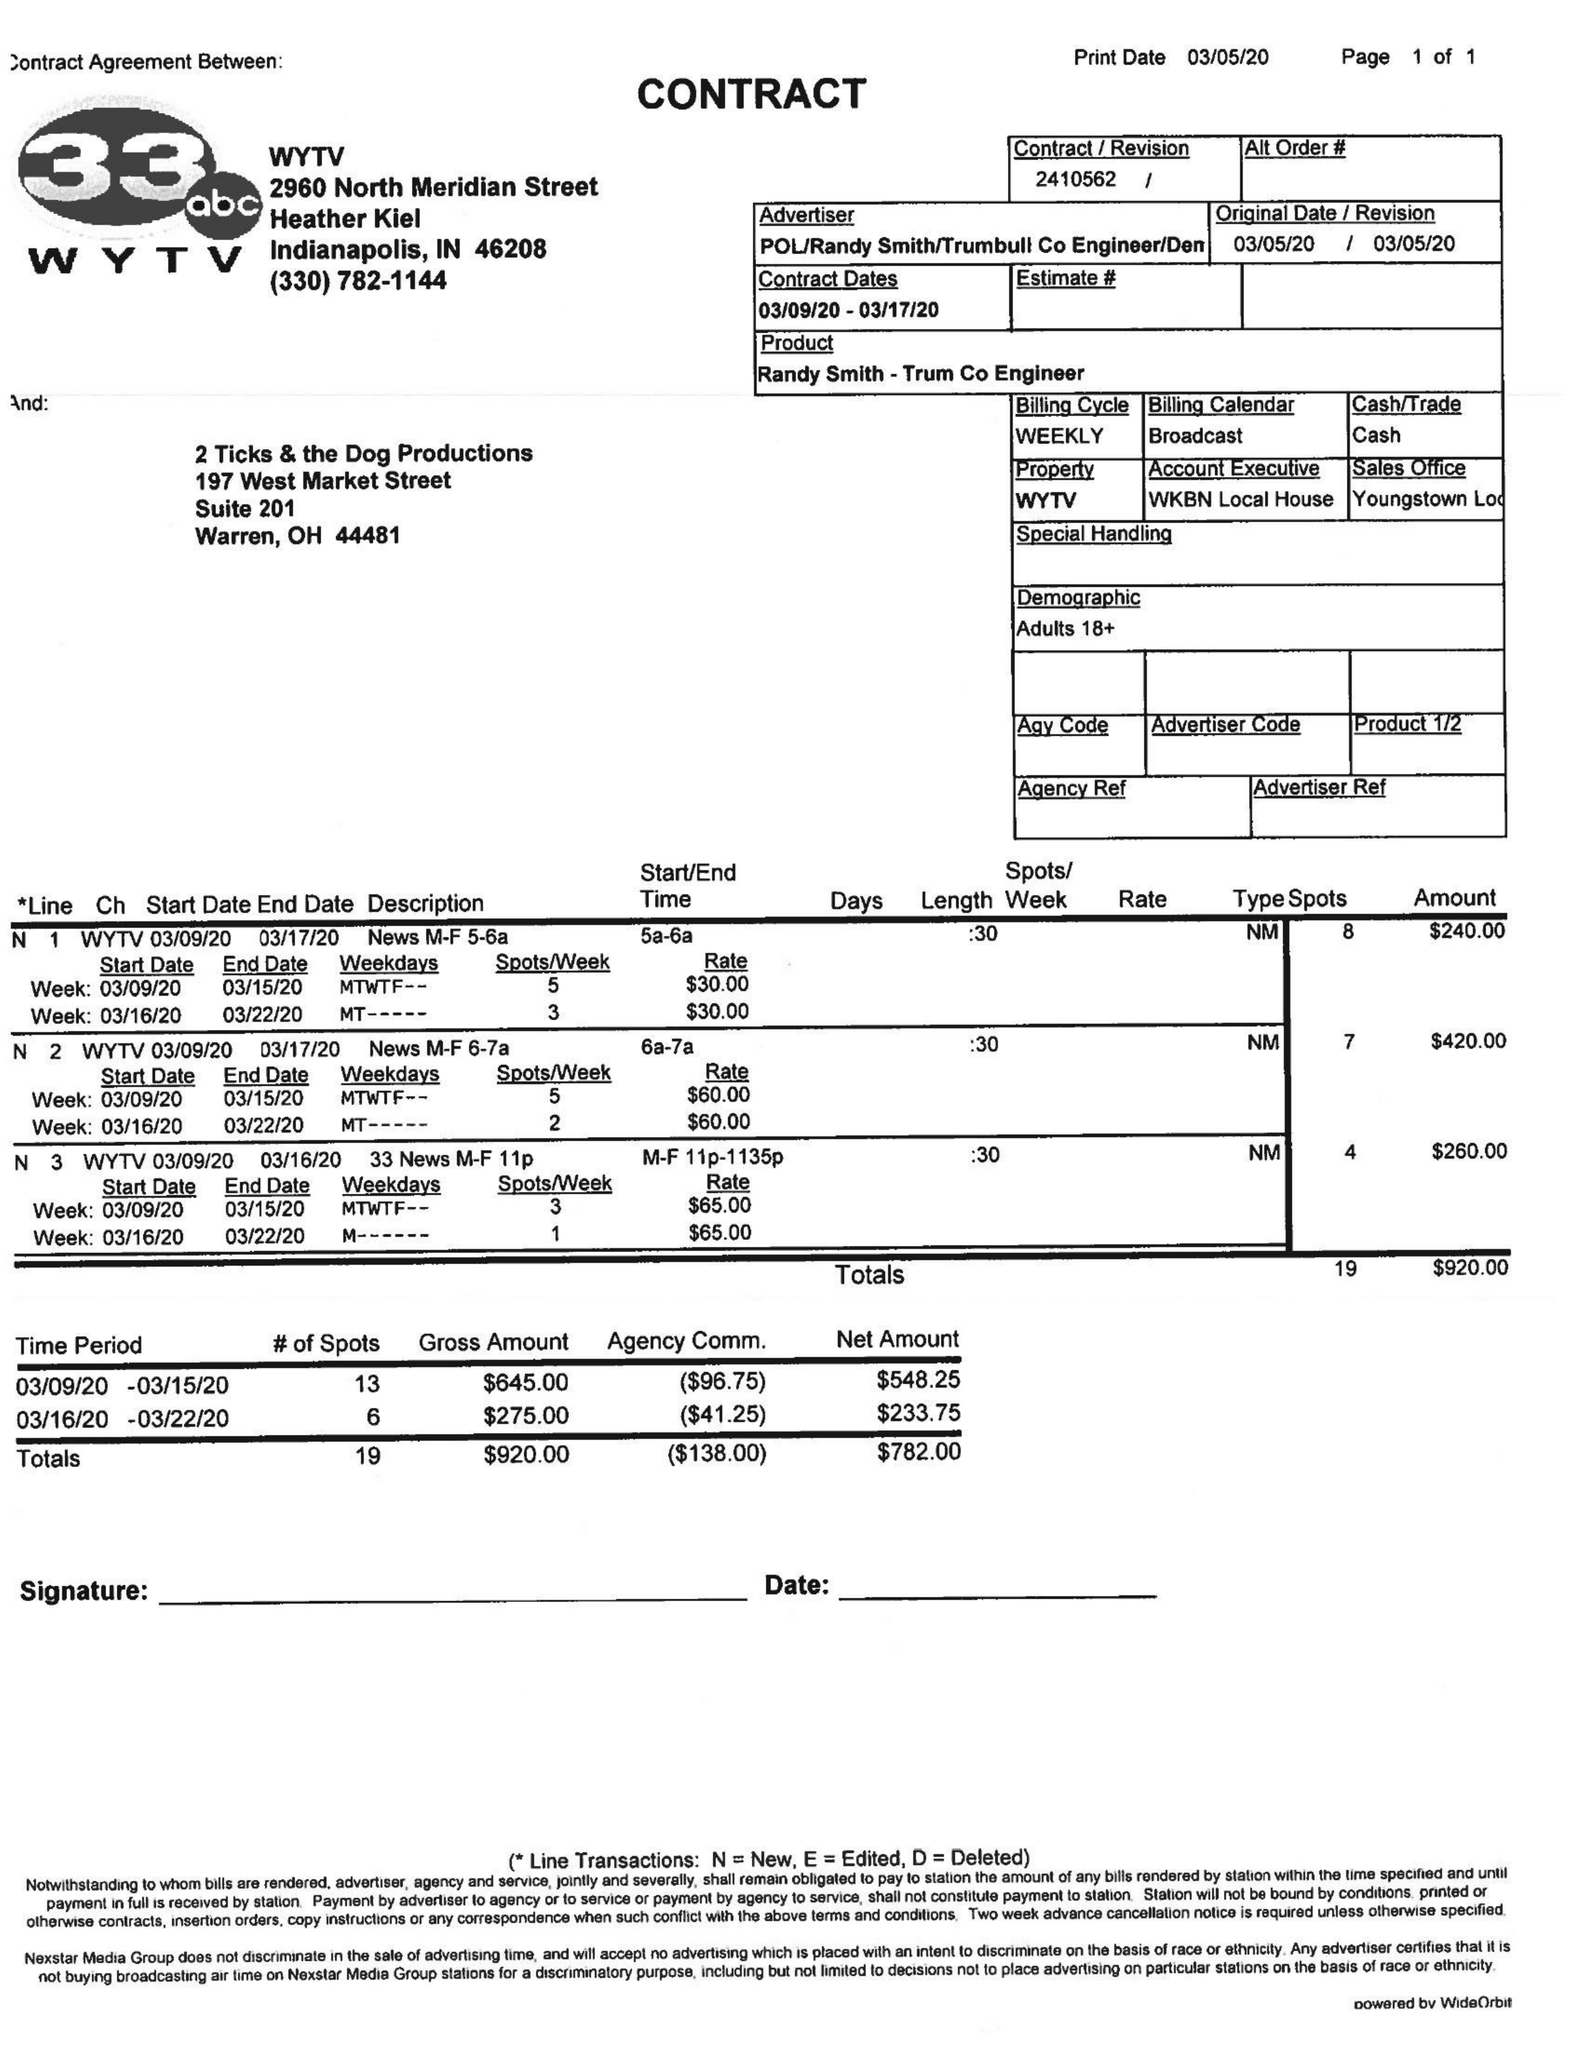What is the value for the advertiser?
Answer the question using a single word or phrase. POL/RANDYSMITH/TRUMBULLCOENGINEER/DEN| 